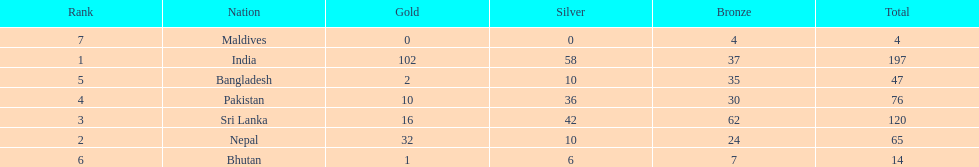Give me the full table as a dictionary. {'header': ['Rank', 'Nation', 'Gold', 'Silver', 'Bronze', 'Total'], 'rows': [['7', 'Maldives', '0', '0', '4', '4'], ['1', 'India', '102', '58', '37', '197'], ['5', 'Bangladesh', '2', '10', '35', '47'], ['4', 'Pakistan', '10', '36', '30', '76'], ['3', 'Sri Lanka', '16', '42', '62', '120'], ['2', 'Nepal', '32', '10', '24', '65'], ['6', 'Bhutan', '1', '6', '7', '14']]} How many gold medals were awarded between all 7 nations? 163. 